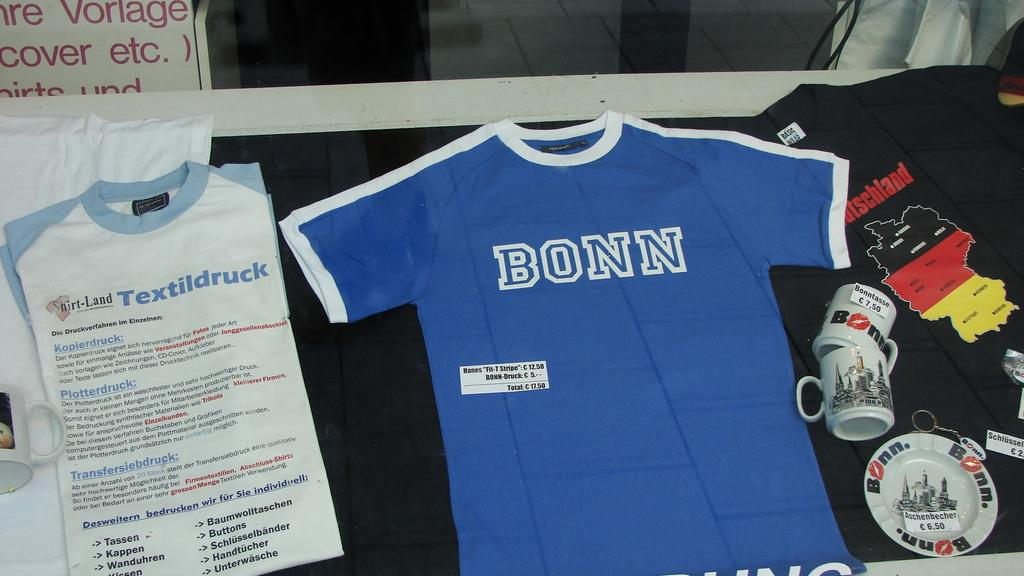<image>
Share a concise interpretation of the image provided. A blue shirt that says Bonn on it next to a shirt full of text. 